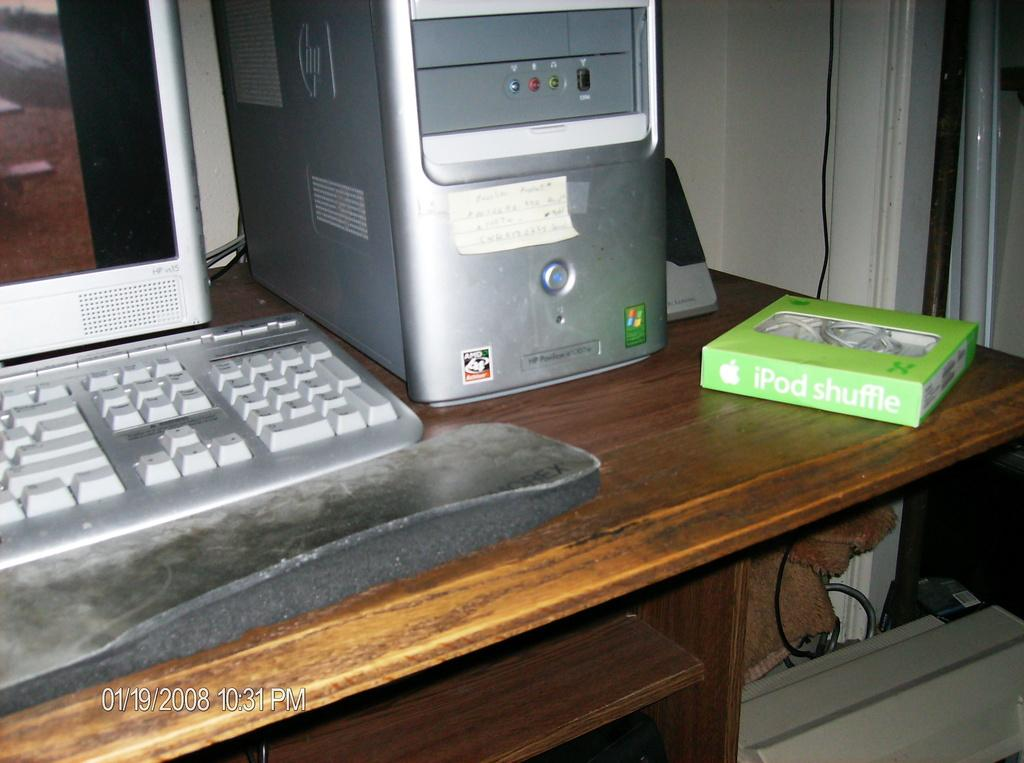What type of electronic device is on the table in the image? There is a monitor on the table in the image. What other electronic device can be seen on the table? There is a keyboard on the table in the image. What is the main component of a computer system that is visible on the table? There is a CPU on the table in the image. What type of product is in a box on the table? There is an iPod shuffle box on the table in the image. How does the monitor wash its nose in the image? The monitor does not have a nose, nor does it perform any actions such as washing, in the image. 